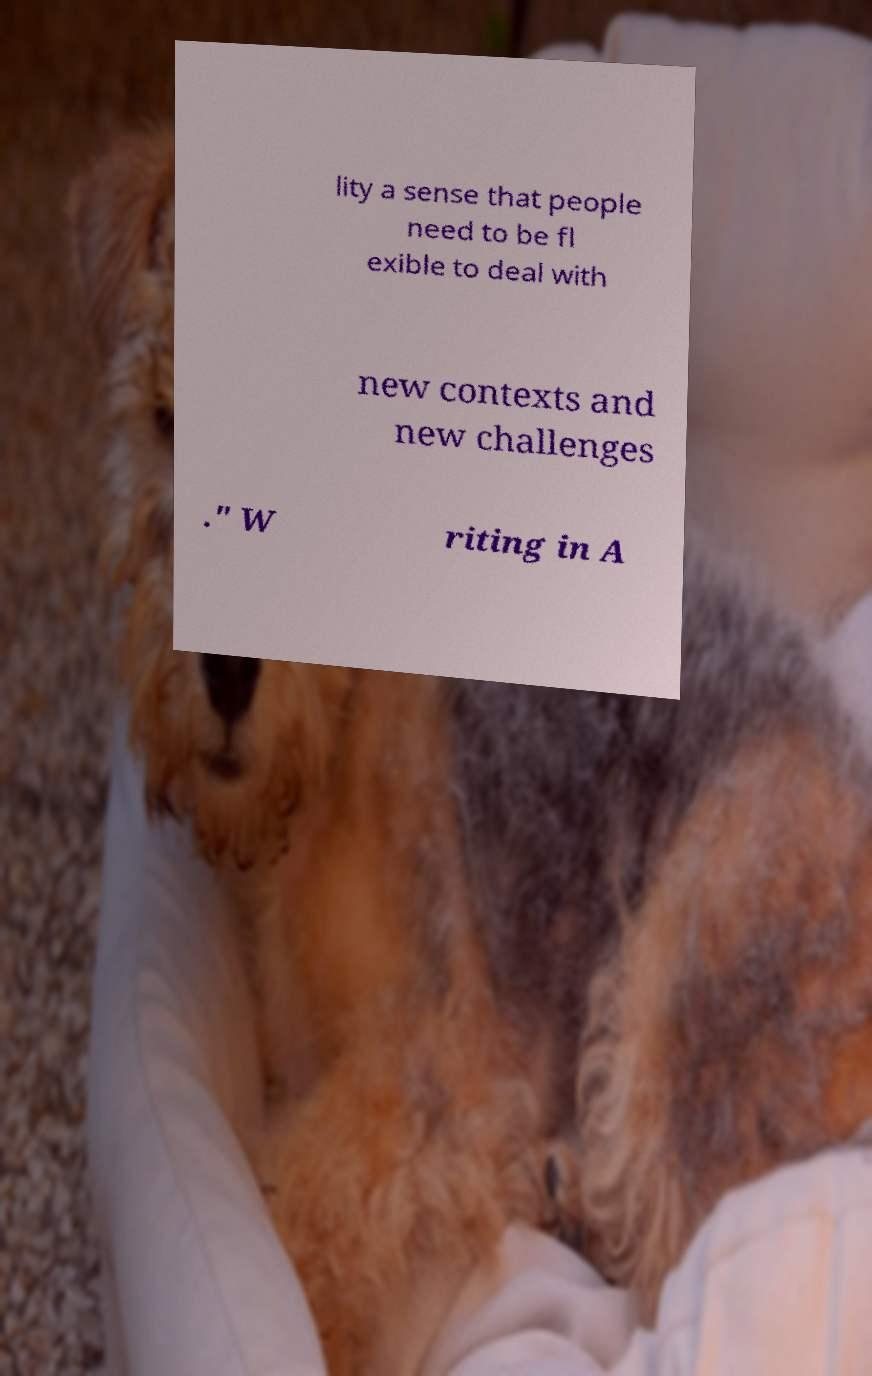Please identify and transcribe the text found in this image. lity a sense that people need to be fl exible to deal with new contexts and new challenges ." W riting in A 